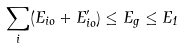<formula> <loc_0><loc_0><loc_500><loc_500>\sum _ { i } ( E _ { i o } + E ^ { \prime } _ { i o } ) \leq E _ { g } \leq E _ { 1 }</formula> 